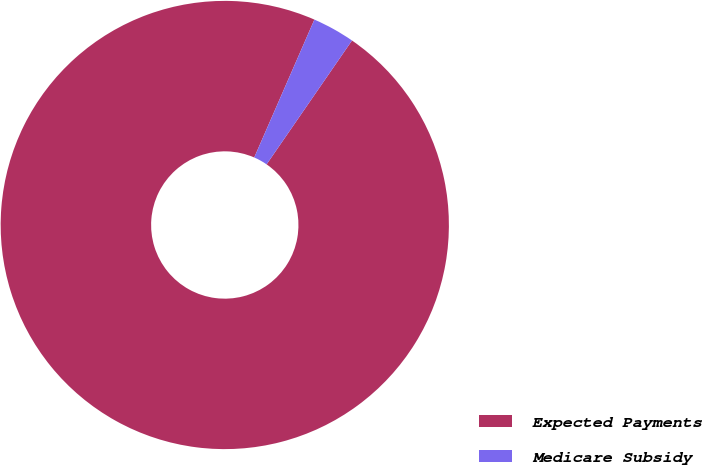Convert chart to OTSL. <chart><loc_0><loc_0><loc_500><loc_500><pie_chart><fcel>Expected Payments<fcel>Medicare Subsidy<nl><fcel>96.94%<fcel>3.06%<nl></chart> 